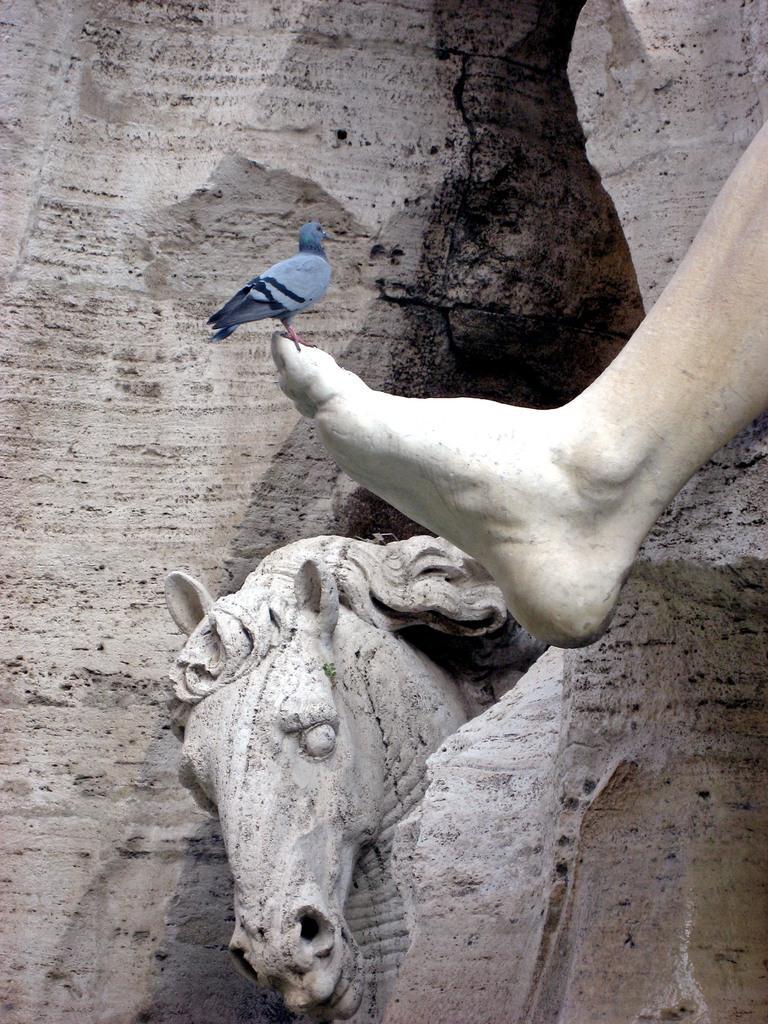Could you give a brief overview of what you see in this image? In the picture we can see a rocky hill in the middle of it, we can see a horse sculpture which is white in color and inside we can see a person's leg and on it we can see a bird standing. 